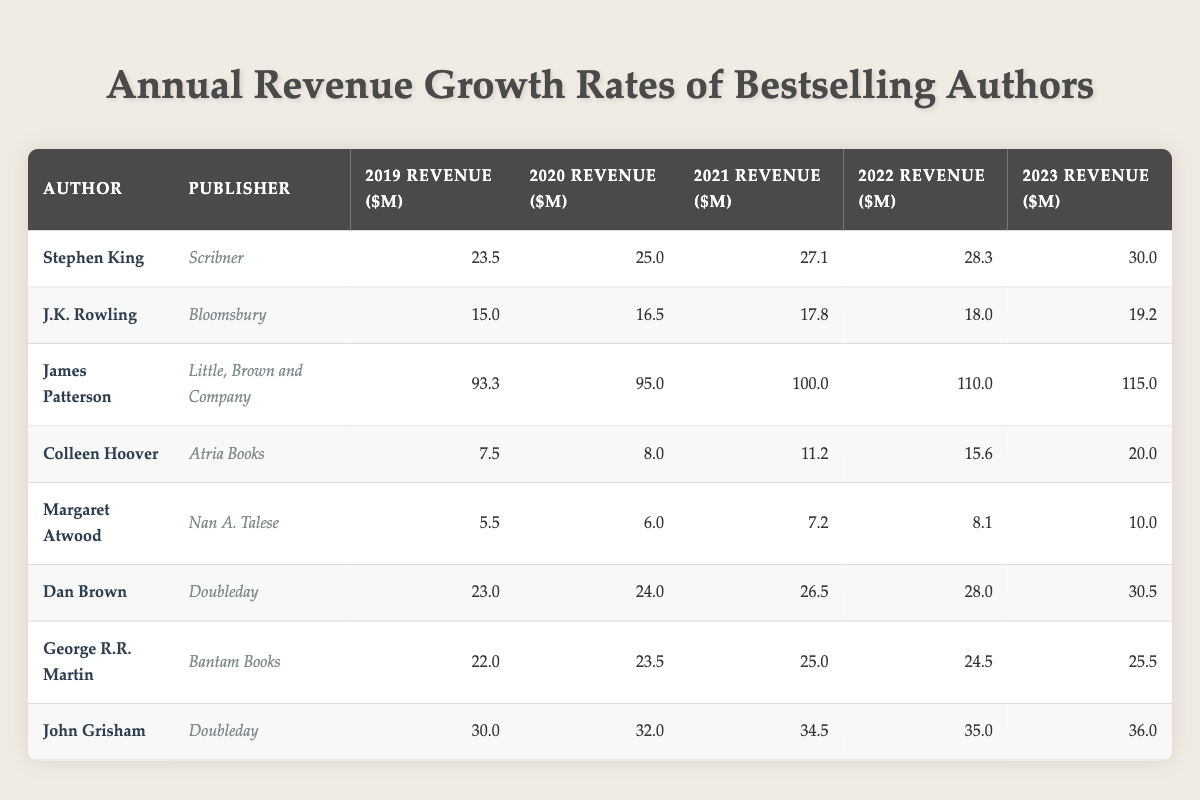What was the revenue of James Patterson in 2021? Looking at the row for James Patterson, the column for 2021 Revenue shows the value as 100.0
Answer: 100.0 Which author had the highest revenue in 2023? Reviewing the 2023 Revenue column, the highest value is 115.0 for James Patterson, which is greater than all other revenues in that year.
Answer: James Patterson What was the revenue growth for Stephen King from 2019 to 2023? To find the growth, subtract the 2019 Revenue (23.5) from the 2023 Revenue (30.0), giving us 30.0 - 23.5 = 6.5.
Answer: 6.5 Did Colleen Hoover have a revenue decrease in any year from 2019 to 2023? Examining the annual revenues for Colleen Hoover, they show an increase each year: 7.5, 8.0, 11.2, 15.6, and 20.0, indicating no decreases occurred.
Answer: No Calculate the average revenue for George R.R. Martin from 2019 to 2023. The revenues from 2019 to 2023 for George R.R. Martin are: 22.0, 23.5, 25.0, 24.5, and 25.5. Summing them gives 120.5, and dividing by 5 gives an average of 120.5 / 5 = 24.1.
Answer: 24.1 Which author had the highest growth rate from 2019 to 2023? First, calculate the growth of each author from 2019 to 2023. For example, Stephen King grew from 23.5 to 30.0, a growth of 6.5. Colleen Hoover grew from 7.5 to 20.0 (12.5), and James Patterson grew from 93.3 to 115.0 (21.7). Comparing these growths shows James Patterson had the highest growth rate.
Answer: James Patterson What was the total revenue for all authors in 2022? Adding the revenues for all authors from the 2022 column: 28.3 + 18.0 + 110.0 + 15.6 + 8.1 + 28.0 + 24.5 + 35.0 equals 339.5.
Answer: 339.5 Is it true that every author listed saw an increase in revenue from 2019 to 2023? Comparing the revenues from 2019 to 2023 for each author indicates all had increases, confirming the statement is true.
Answer: True 